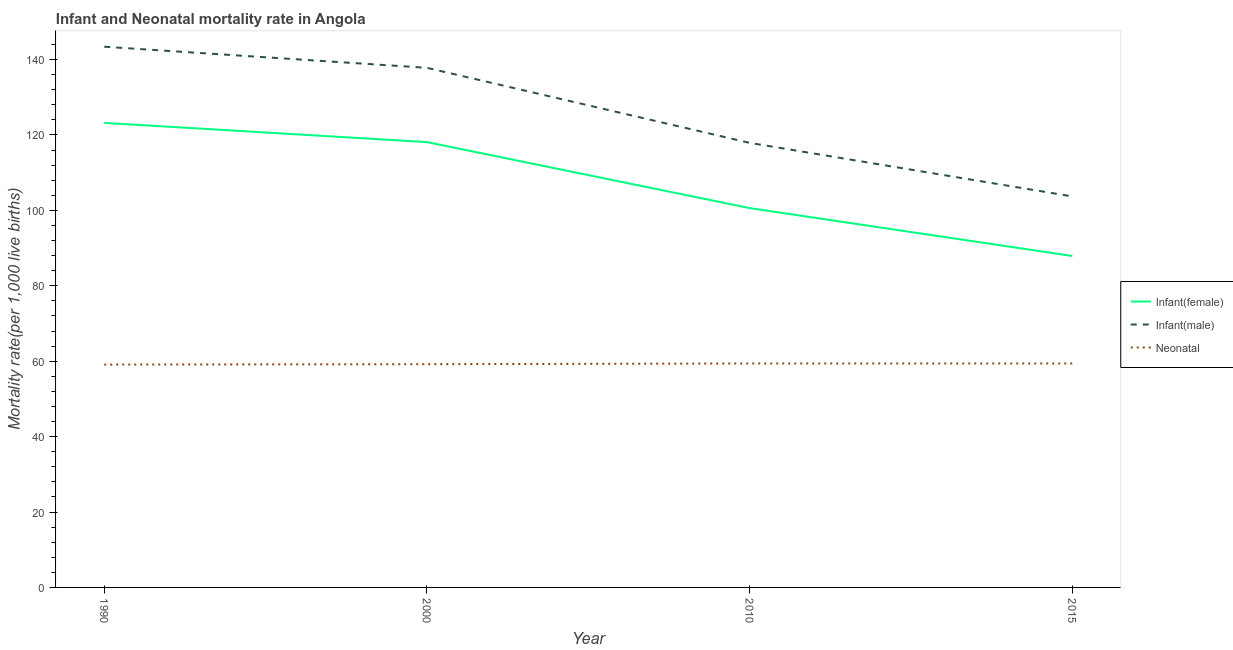How many different coloured lines are there?
Offer a very short reply. 3. Does the line corresponding to infant mortality rate(female) intersect with the line corresponding to neonatal mortality rate?
Offer a very short reply. No. Is the number of lines equal to the number of legend labels?
Keep it short and to the point. Yes. What is the neonatal mortality rate in 2000?
Your answer should be compact. 59.2. Across all years, what is the maximum neonatal mortality rate?
Provide a succinct answer. 59.4. Across all years, what is the minimum infant mortality rate(male)?
Offer a terse response. 103.7. In which year was the infant mortality rate(male) minimum?
Make the answer very short. 2015. What is the total neonatal mortality rate in the graph?
Offer a very short reply. 237.1. What is the difference between the infant mortality rate(female) in 2000 and that in 2015?
Your answer should be compact. 30.2. What is the difference between the infant mortality rate(male) in 1990 and the neonatal mortality rate in 2000?
Offer a very short reply. 84.2. What is the average infant mortality rate(male) per year?
Your response must be concise. 125.7. In the year 2000, what is the difference between the infant mortality rate(male) and neonatal mortality rate?
Your answer should be compact. 78.6. In how many years, is the infant mortality rate(male) greater than 120?
Give a very brief answer. 2. What is the ratio of the infant mortality rate(female) in 2000 to that in 2010?
Provide a short and direct response. 1.17. Is the infant mortality rate(male) in 1990 less than that in 2000?
Provide a succinct answer. No. What is the difference between the highest and the second highest infant mortality rate(male)?
Give a very brief answer. 5.6. What is the difference between the highest and the lowest infant mortality rate(female)?
Provide a succinct answer. 35.3. Is the sum of the infant mortality rate(female) in 1990 and 2010 greater than the maximum infant mortality rate(male) across all years?
Your response must be concise. Yes. What is the difference between two consecutive major ticks on the Y-axis?
Your answer should be very brief. 20. Does the graph contain any zero values?
Offer a terse response. No. How many legend labels are there?
Keep it short and to the point. 3. How are the legend labels stacked?
Offer a terse response. Vertical. What is the title of the graph?
Make the answer very short. Infant and Neonatal mortality rate in Angola. What is the label or title of the X-axis?
Your response must be concise. Year. What is the label or title of the Y-axis?
Your response must be concise. Mortality rate(per 1,0 live births). What is the Mortality rate(per 1,000 live births) of Infant(female) in 1990?
Make the answer very short. 123.2. What is the Mortality rate(per 1,000 live births) in Infant(male) in 1990?
Your answer should be very brief. 143.4. What is the Mortality rate(per 1,000 live births) of Neonatal  in 1990?
Provide a succinct answer. 59.1. What is the Mortality rate(per 1,000 live births) of Infant(female) in 2000?
Offer a terse response. 118.1. What is the Mortality rate(per 1,000 live births) of Infant(male) in 2000?
Keep it short and to the point. 137.8. What is the Mortality rate(per 1,000 live births) in Neonatal  in 2000?
Provide a succinct answer. 59.2. What is the Mortality rate(per 1,000 live births) in Infant(female) in 2010?
Give a very brief answer. 100.6. What is the Mortality rate(per 1,000 live births) in Infant(male) in 2010?
Provide a succinct answer. 117.9. What is the Mortality rate(per 1,000 live births) in Neonatal  in 2010?
Offer a very short reply. 59.4. What is the Mortality rate(per 1,000 live births) of Infant(female) in 2015?
Offer a very short reply. 87.9. What is the Mortality rate(per 1,000 live births) in Infant(male) in 2015?
Offer a very short reply. 103.7. What is the Mortality rate(per 1,000 live births) of Neonatal  in 2015?
Your response must be concise. 59.4. Across all years, what is the maximum Mortality rate(per 1,000 live births) of Infant(female)?
Give a very brief answer. 123.2. Across all years, what is the maximum Mortality rate(per 1,000 live births) in Infant(male)?
Your answer should be very brief. 143.4. Across all years, what is the maximum Mortality rate(per 1,000 live births) of Neonatal ?
Give a very brief answer. 59.4. Across all years, what is the minimum Mortality rate(per 1,000 live births) in Infant(female)?
Make the answer very short. 87.9. Across all years, what is the minimum Mortality rate(per 1,000 live births) in Infant(male)?
Provide a succinct answer. 103.7. Across all years, what is the minimum Mortality rate(per 1,000 live births) of Neonatal ?
Provide a short and direct response. 59.1. What is the total Mortality rate(per 1,000 live births) of Infant(female) in the graph?
Give a very brief answer. 429.8. What is the total Mortality rate(per 1,000 live births) of Infant(male) in the graph?
Offer a very short reply. 502.8. What is the total Mortality rate(per 1,000 live births) in Neonatal  in the graph?
Make the answer very short. 237.1. What is the difference between the Mortality rate(per 1,000 live births) of Infant(female) in 1990 and that in 2000?
Ensure brevity in your answer.  5.1. What is the difference between the Mortality rate(per 1,000 live births) of Neonatal  in 1990 and that in 2000?
Your answer should be compact. -0.1. What is the difference between the Mortality rate(per 1,000 live births) of Infant(female) in 1990 and that in 2010?
Provide a short and direct response. 22.6. What is the difference between the Mortality rate(per 1,000 live births) in Infant(male) in 1990 and that in 2010?
Ensure brevity in your answer.  25.5. What is the difference between the Mortality rate(per 1,000 live births) of Infant(female) in 1990 and that in 2015?
Make the answer very short. 35.3. What is the difference between the Mortality rate(per 1,000 live births) in Infant(male) in 1990 and that in 2015?
Give a very brief answer. 39.7. What is the difference between the Mortality rate(per 1,000 live births) of Infant(female) in 2000 and that in 2015?
Give a very brief answer. 30.2. What is the difference between the Mortality rate(per 1,000 live births) of Infant(male) in 2000 and that in 2015?
Offer a terse response. 34.1. What is the difference between the Mortality rate(per 1,000 live births) of Infant(female) in 2010 and that in 2015?
Offer a very short reply. 12.7. What is the difference between the Mortality rate(per 1,000 live births) in Infant(male) in 2010 and that in 2015?
Offer a terse response. 14.2. What is the difference between the Mortality rate(per 1,000 live births) of Infant(female) in 1990 and the Mortality rate(per 1,000 live births) of Infant(male) in 2000?
Offer a very short reply. -14.6. What is the difference between the Mortality rate(per 1,000 live births) of Infant(male) in 1990 and the Mortality rate(per 1,000 live births) of Neonatal  in 2000?
Your answer should be very brief. 84.2. What is the difference between the Mortality rate(per 1,000 live births) of Infant(female) in 1990 and the Mortality rate(per 1,000 live births) of Infant(male) in 2010?
Your response must be concise. 5.3. What is the difference between the Mortality rate(per 1,000 live births) in Infant(female) in 1990 and the Mortality rate(per 1,000 live births) in Neonatal  in 2010?
Provide a short and direct response. 63.8. What is the difference between the Mortality rate(per 1,000 live births) of Infant(male) in 1990 and the Mortality rate(per 1,000 live births) of Neonatal  in 2010?
Your response must be concise. 84. What is the difference between the Mortality rate(per 1,000 live births) in Infant(female) in 1990 and the Mortality rate(per 1,000 live births) in Infant(male) in 2015?
Your answer should be very brief. 19.5. What is the difference between the Mortality rate(per 1,000 live births) in Infant(female) in 1990 and the Mortality rate(per 1,000 live births) in Neonatal  in 2015?
Provide a succinct answer. 63.8. What is the difference between the Mortality rate(per 1,000 live births) of Infant(female) in 2000 and the Mortality rate(per 1,000 live births) of Neonatal  in 2010?
Ensure brevity in your answer.  58.7. What is the difference between the Mortality rate(per 1,000 live births) in Infant(male) in 2000 and the Mortality rate(per 1,000 live births) in Neonatal  in 2010?
Give a very brief answer. 78.4. What is the difference between the Mortality rate(per 1,000 live births) in Infant(female) in 2000 and the Mortality rate(per 1,000 live births) in Neonatal  in 2015?
Give a very brief answer. 58.7. What is the difference between the Mortality rate(per 1,000 live births) of Infant(male) in 2000 and the Mortality rate(per 1,000 live births) of Neonatal  in 2015?
Ensure brevity in your answer.  78.4. What is the difference between the Mortality rate(per 1,000 live births) in Infant(female) in 2010 and the Mortality rate(per 1,000 live births) in Neonatal  in 2015?
Make the answer very short. 41.2. What is the difference between the Mortality rate(per 1,000 live births) of Infant(male) in 2010 and the Mortality rate(per 1,000 live births) of Neonatal  in 2015?
Provide a short and direct response. 58.5. What is the average Mortality rate(per 1,000 live births) in Infant(female) per year?
Ensure brevity in your answer.  107.45. What is the average Mortality rate(per 1,000 live births) of Infant(male) per year?
Offer a very short reply. 125.7. What is the average Mortality rate(per 1,000 live births) in Neonatal  per year?
Your response must be concise. 59.27. In the year 1990, what is the difference between the Mortality rate(per 1,000 live births) of Infant(female) and Mortality rate(per 1,000 live births) of Infant(male)?
Your answer should be very brief. -20.2. In the year 1990, what is the difference between the Mortality rate(per 1,000 live births) in Infant(female) and Mortality rate(per 1,000 live births) in Neonatal ?
Your answer should be very brief. 64.1. In the year 1990, what is the difference between the Mortality rate(per 1,000 live births) of Infant(male) and Mortality rate(per 1,000 live births) of Neonatal ?
Ensure brevity in your answer.  84.3. In the year 2000, what is the difference between the Mortality rate(per 1,000 live births) of Infant(female) and Mortality rate(per 1,000 live births) of Infant(male)?
Offer a terse response. -19.7. In the year 2000, what is the difference between the Mortality rate(per 1,000 live births) in Infant(female) and Mortality rate(per 1,000 live births) in Neonatal ?
Give a very brief answer. 58.9. In the year 2000, what is the difference between the Mortality rate(per 1,000 live births) in Infant(male) and Mortality rate(per 1,000 live births) in Neonatal ?
Your response must be concise. 78.6. In the year 2010, what is the difference between the Mortality rate(per 1,000 live births) of Infant(female) and Mortality rate(per 1,000 live births) of Infant(male)?
Ensure brevity in your answer.  -17.3. In the year 2010, what is the difference between the Mortality rate(per 1,000 live births) of Infant(female) and Mortality rate(per 1,000 live births) of Neonatal ?
Keep it short and to the point. 41.2. In the year 2010, what is the difference between the Mortality rate(per 1,000 live births) of Infant(male) and Mortality rate(per 1,000 live births) of Neonatal ?
Offer a very short reply. 58.5. In the year 2015, what is the difference between the Mortality rate(per 1,000 live births) of Infant(female) and Mortality rate(per 1,000 live births) of Infant(male)?
Your response must be concise. -15.8. In the year 2015, what is the difference between the Mortality rate(per 1,000 live births) of Infant(female) and Mortality rate(per 1,000 live births) of Neonatal ?
Provide a succinct answer. 28.5. In the year 2015, what is the difference between the Mortality rate(per 1,000 live births) of Infant(male) and Mortality rate(per 1,000 live births) of Neonatal ?
Offer a terse response. 44.3. What is the ratio of the Mortality rate(per 1,000 live births) of Infant(female) in 1990 to that in 2000?
Provide a succinct answer. 1.04. What is the ratio of the Mortality rate(per 1,000 live births) in Infant(male) in 1990 to that in 2000?
Keep it short and to the point. 1.04. What is the ratio of the Mortality rate(per 1,000 live births) of Infant(female) in 1990 to that in 2010?
Provide a succinct answer. 1.22. What is the ratio of the Mortality rate(per 1,000 live births) in Infant(male) in 1990 to that in 2010?
Your response must be concise. 1.22. What is the ratio of the Mortality rate(per 1,000 live births) of Neonatal  in 1990 to that in 2010?
Provide a short and direct response. 0.99. What is the ratio of the Mortality rate(per 1,000 live births) of Infant(female) in 1990 to that in 2015?
Your answer should be very brief. 1.4. What is the ratio of the Mortality rate(per 1,000 live births) in Infant(male) in 1990 to that in 2015?
Provide a short and direct response. 1.38. What is the ratio of the Mortality rate(per 1,000 live births) in Neonatal  in 1990 to that in 2015?
Your response must be concise. 0.99. What is the ratio of the Mortality rate(per 1,000 live births) of Infant(female) in 2000 to that in 2010?
Provide a short and direct response. 1.17. What is the ratio of the Mortality rate(per 1,000 live births) in Infant(male) in 2000 to that in 2010?
Offer a very short reply. 1.17. What is the ratio of the Mortality rate(per 1,000 live births) in Neonatal  in 2000 to that in 2010?
Make the answer very short. 1. What is the ratio of the Mortality rate(per 1,000 live births) in Infant(female) in 2000 to that in 2015?
Your answer should be very brief. 1.34. What is the ratio of the Mortality rate(per 1,000 live births) of Infant(male) in 2000 to that in 2015?
Your answer should be compact. 1.33. What is the ratio of the Mortality rate(per 1,000 live births) of Neonatal  in 2000 to that in 2015?
Give a very brief answer. 1. What is the ratio of the Mortality rate(per 1,000 live births) in Infant(female) in 2010 to that in 2015?
Keep it short and to the point. 1.14. What is the ratio of the Mortality rate(per 1,000 live births) in Infant(male) in 2010 to that in 2015?
Make the answer very short. 1.14. What is the difference between the highest and the second highest Mortality rate(per 1,000 live births) in Infant(female)?
Give a very brief answer. 5.1. What is the difference between the highest and the second highest Mortality rate(per 1,000 live births) of Neonatal ?
Keep it short and to the point. 0. What is the difference between the highest and the lowest Mortality rate(per 1,000 live births) of Infant(female)?
Keep it short and to the point. 35.3. What is the difference between the highest and the lowest Mortality rate(per 1,000 live births) of Infant(male)?
Ensure brevity in your answer.  39.7. 